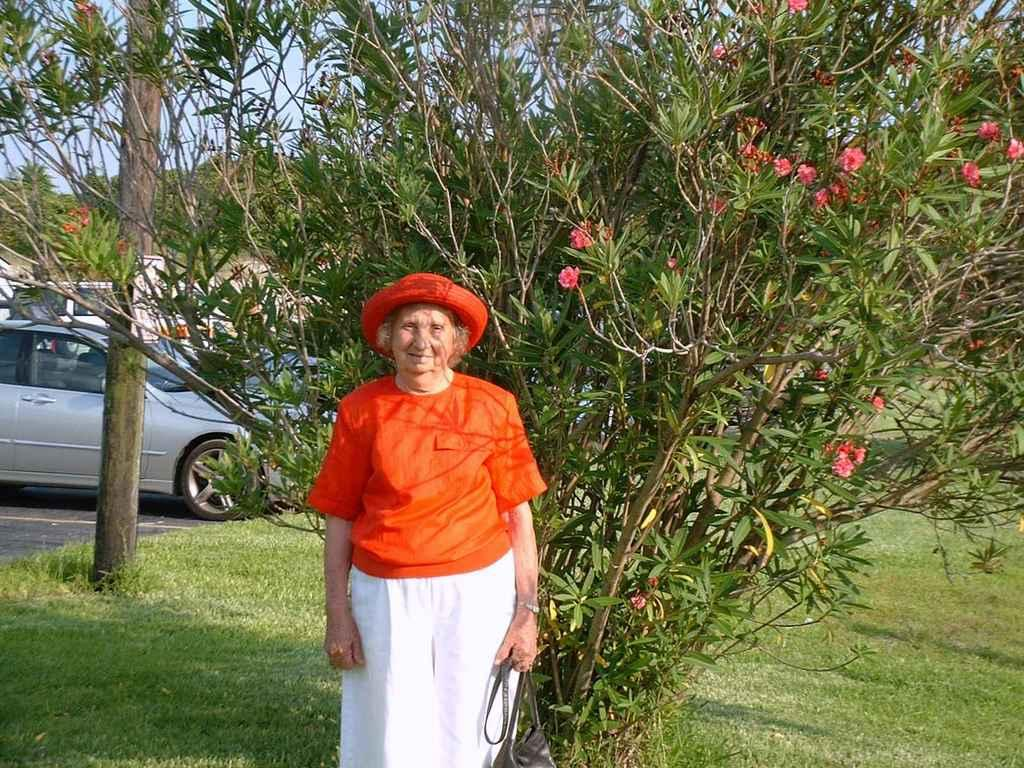Who is the main subject in the image? There is an old lady in the image. What is the old lady holding? The old lady is holding a bag. What is the old lady wearing on her head? The old lady is wearing a hat. What expression does the old lady have? The old lady is smiling. What can be seen in the background of the image? There are trees, flowers, grass, vehicles, and the sky visible in the background of the image. How many mice are running around the old lady's feet in the image? There are no mice present in the image. What type of crowd can be seen gathering around the old lady in the image? There is no crowd present in the image; it features the old lady alone. 